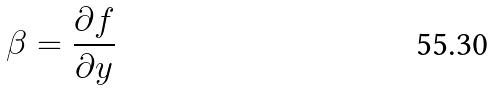<formula> <loc_0><loc_0><loc_500><loc_500>\beta = \frac { \partial f } { \partial y }</formula> 